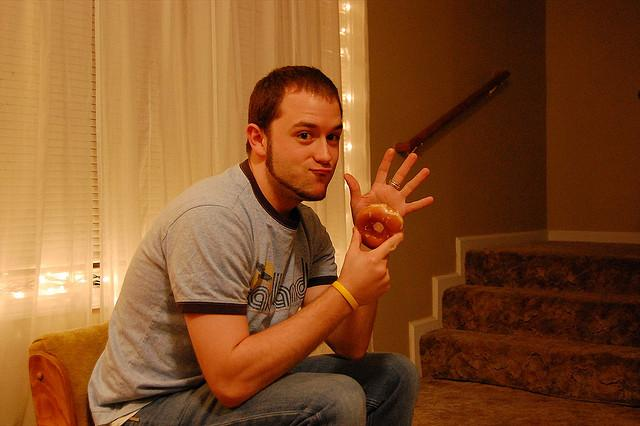What flavor is the donut? glazed 